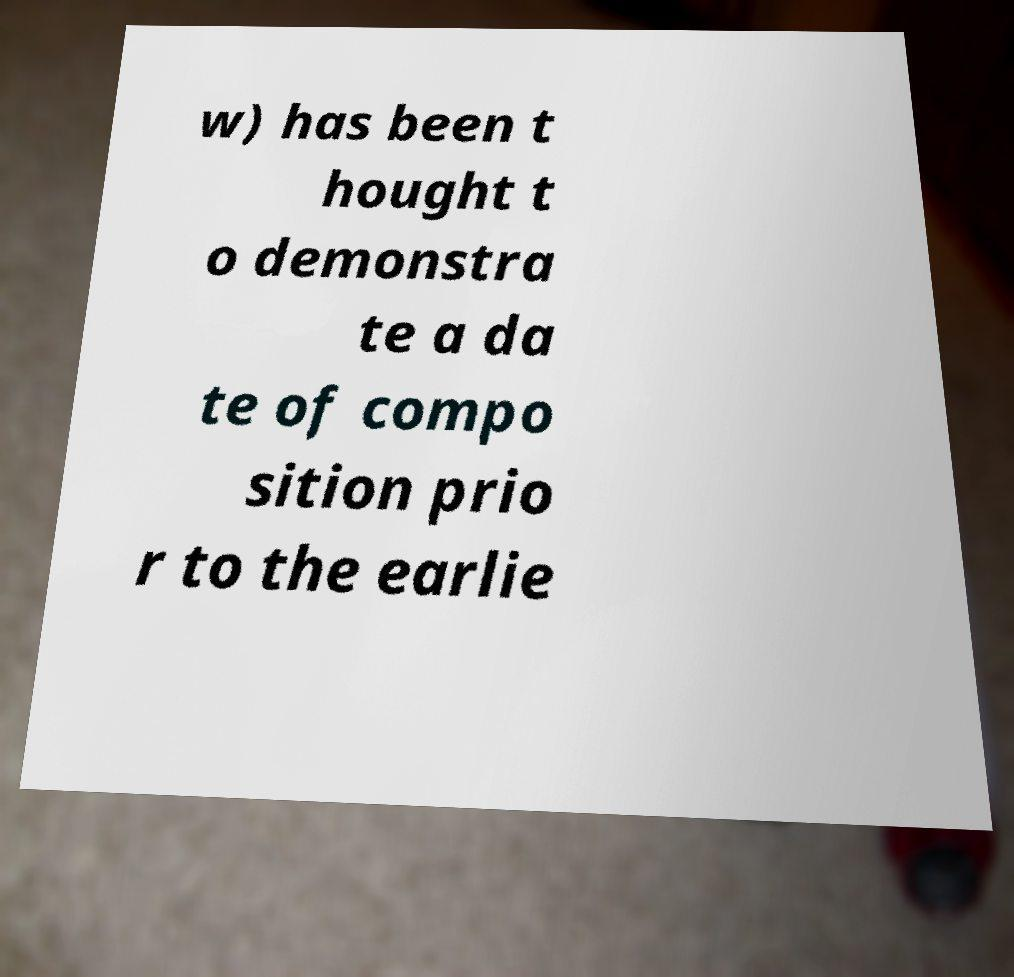Please identify and transcribe the text found in this image. w) has been t hought t o demonstra te a da te of compo sition prio r to the earlie 